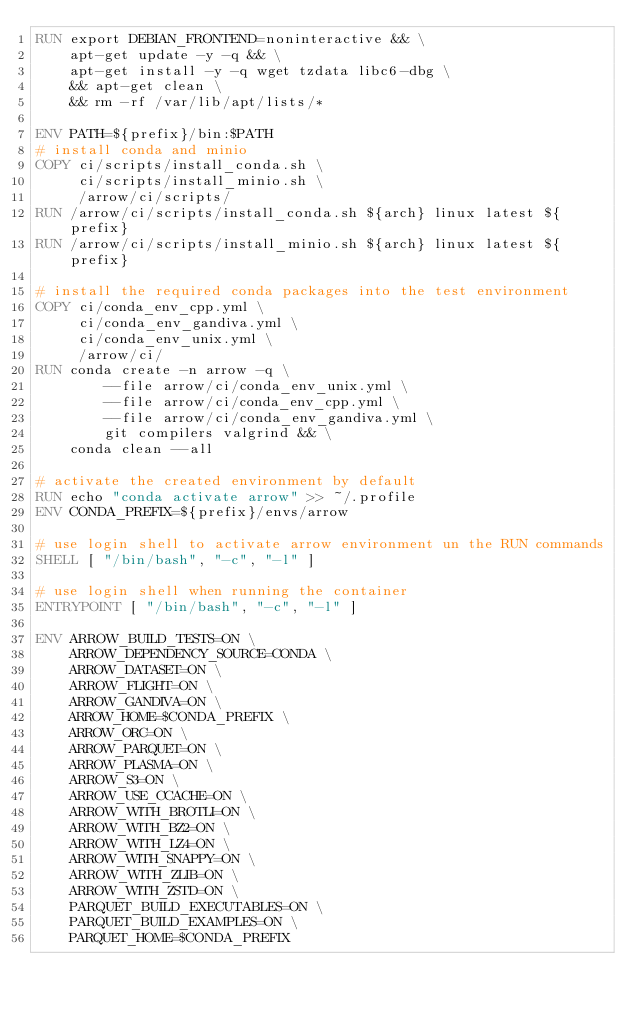Convert code to text. <code><loc_0><loc_0><loc_500><loc_500><_Dockerfile_>RUN export DEBIAN_FRONTEND=noninteractive && \
    apt-get update -y -q && \
    apt-get install -y -q wget tzdata libc6-dbg \
    && apt-get clean \
    && rm -rf /var/lib/apt/lists/*

ENV PATH=${prefix}/bin:$PATH
# install conda and minio
COPY ci/scripts/install_conda.sh \
     ci/scripts/install_minio.sh \
     /arrow/ci/scripts/
RUN /arrow/ci/scripts/install_conda.sh ${arch} linux latest ${prefix}
RUN /arrow/ci/scripts/install_minio.sh ${arch} linux latest ${prefix}

# install the required conda packages into the test environment
COPY ci/conda_env_cpp.yml \
     ci/conda_env_gandiva.yml \
     ci/conda_env_unix.yml \
     /arrow/ci/
RUN conda create -n arrow -q \
        --file arrow/ci/conda_env_unix.yml \
        --file arrow/ci/conda_env_cpp.yml \
        --file arrow/ci/conda_env_gandiva.yml \
        git compilers valgrind && \
    conda clean --all

# activate the created environment by default
RUN echo "conda activate arrow" >> ~/.profile
ENV CONDA_PREFIX=${prefix}/envs/arrow

# use login shell to activate arrow environment un the RUN commands
SHELL [ "/bin/bash", "-c", "-l" ]

# use login shell when running the container
ENTRYPOINT [ "/bin/bash", "-c", "-l" ]

ENV ARROW_BUILD_TESTS=ON \
    ARROW_DEPENDENCY_SOURCE=CONDA \
    ARROW_DATASET=ON \
    ARROW_FLIGHT=ON \
    ARROW_GANDIVA=ON \
    ARROW_HOME=$CONDA_PREFIX \
    ARROW_ORC=ON \
    ARROW_PARQUET=ON \
    ARROW_PLASMA=ON \
    ARROW_S3=ON \
    ARROW_USE_CCACHE=ON \
    ARROW_WITH_BROTLI=ON \
    ARROW_WITH_BZ2=ON \
    ARROW_WITH_LZ4=ON \
    ARROW_WITH_SNAPPY=ON \
    ARROW_WITH_ZLIB=ON \
    ARROW_WITH_ZSTD=ON \
    PARQUET_BUILD_EXECUTABLES=ON \
    PARQUET_BUILD_EXAMPLES=ON \
    PARQUET_HOME=$CONDA_PREFIX
</code> 